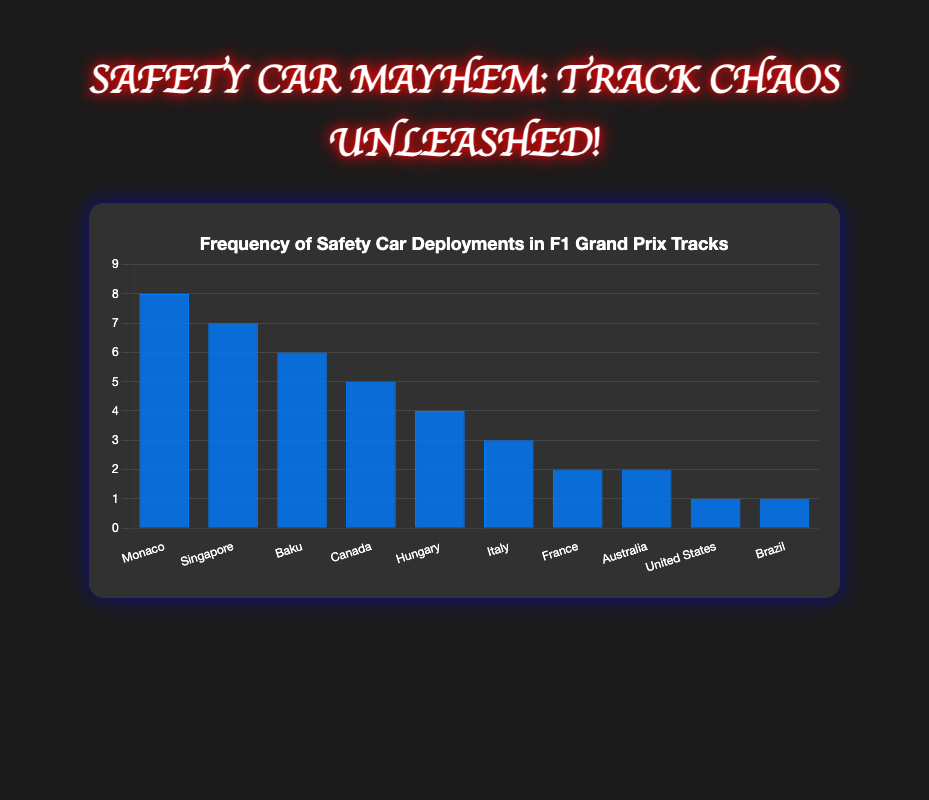What is the total number of safety car deployments across all tracks? Sum the number of deployments for each track: 8 (Monaco) + 7 (Singapore) + 6 (Baku) + 5 (Canada) + 4 (Hungary) + 3 (Italy) + 2 (France) + 2 (Australia) + 1 (United States) + 1 (Brazil). Therefore, 8 + 7 + 6 + 5 + 4 + 3 + 2 + 2 + 1 + 1 = 39.
Answer: 39 Which Grand Prix track has the highest frequency of safety car deployments? Compare the frequencies of all tracks. Monaco has the highest frequency with 8 deployments.
Answer: Monaco How many more safety car deployments does Monaco have compared to Hungary? Monaco has 8 deployments and Hungary has 4. So, the difference is 8 - 4 = 4.
Answer: 4 Which tracks have the same number of safety car deployments? The figure shows that France and Australia both have 2 deployments, while United States and Brazil each have 1 deployment.
Answer: France and Australia, United States and Brazil What is the average number of safety car deployments per track? Sum the total number of deployments and divide by the number of tracks. Total deployments are 39, and there are 10 tracks, so the average is 39/10 = 3.9.
Answer: 3.9 Which track has fewer safety car deployments, Canada or Italy? Compare the frequencies of the two tracks. Canada has 5 and Italy has 3, so Italy has fewer deployments.
Answer: Italy What is the ratio of safety car deployments between Singapore and Baku? Singapore has 7 deployments, and Baku has 6. The ratio is 7:6.
Answer: 7:6 If the deployments for Brazil and the United States were combined into one track, how many total deployments would that new category have? Sum the deployments of Brazil and United States: 1 (Brazil) + 1 (United States) = 2.
Answer: 2 What is the difference in the number of deployments between the track with the most and the track with the least deployments? Monaco has the most with 8 deployments, and both United States and Brazil have the least with 1 each. The difference is 8 - 1 = 7.
Answer: 7 Which track has a deployment frequency closest to the average number of deployments per track? The average number of deployments per track is 3.9. Hungary has 4 deployments, which is closest to 3.9.
Answer: Hungary 